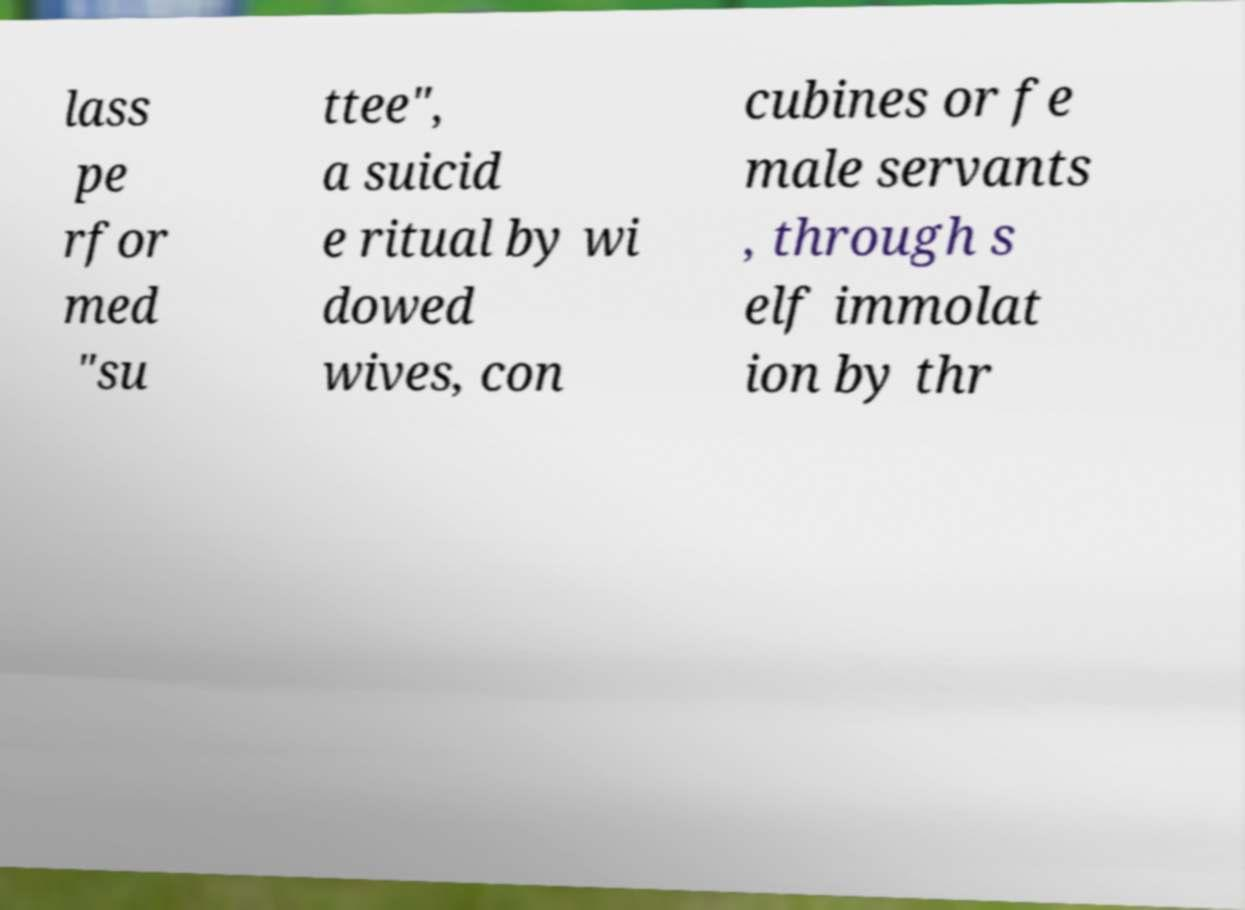Could you extract and type out the text from this image? lass pe rfor med "su ttee", a suicid e ritual by wi dowed wives, con cubines or fe male servants , through s elf immolat ion by thr 